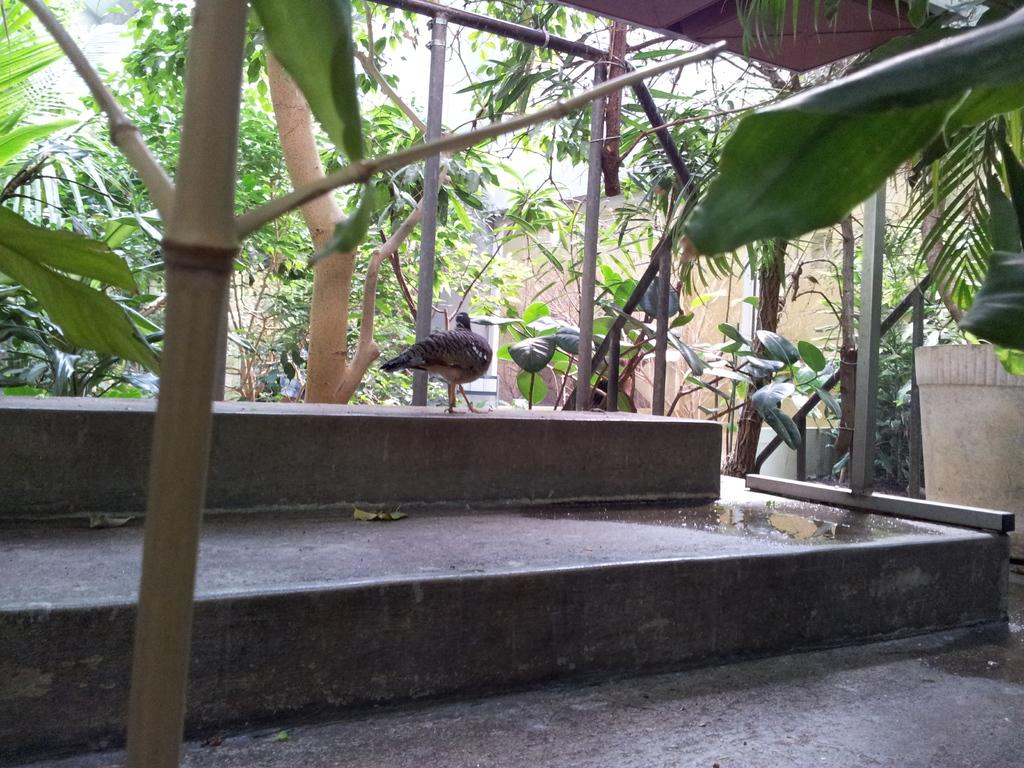What type of animal can be seen in the picture? There is a bird in the picture. Where is the bird located in the picture? The bird is on a platform. What other objects are present in the picture? There are poles in the picture. What can be seen in the background of the picture? There are trees in the background of the picture. Reasoning: Let' Let's think step by step in order to produce the conversation. We start by identifying the main subject in the picture, which is the bird. Then, we describe the bird's location, which is on a platform. Next, we mention other objects present in the picture, such as poles. Finally, we describe the background of the picture, which includes trees. Absurd Question/Answer: What type of vegetable is growing on the bird's head in the picture? There is no vegetable growing on the bird's head in the picture. What color are the jeans that the bird is wearing in the picture? Birds do not wear jeans, and there is no clothing visible on the bird in the picture. 